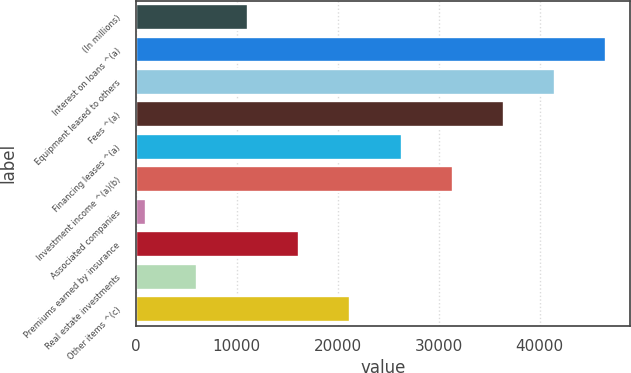Convert chart to OTSL. <chart><loc_0><loc_0><loc_500><loc_500><bar_chart><fcel>(In millions)<fcel>Interest on loans ^(a)<fcel>Equipment leased to others<fcel>Fees ^(a)<fcel>Financing leases ^(a)<fcel>Investment income ^(a)(b)<fcel>Associated companies<fcel>Premiums earned by insurance<fcel>Real estate investments<fcel>Other items ^(c)<nl><fcel>11143.2<fcel>46619.9<fcel>41551.8<fcel>36483.7<fcel>26347.5<fcel>31415.6<fcel>1007<fcel>16211.3<fcel>6075.1<fcel>21279.4<nl></chart> 